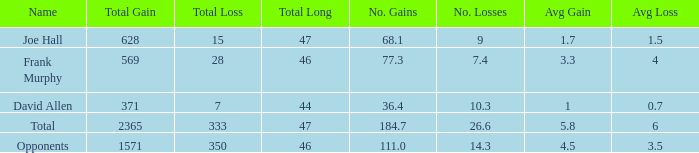Which Avg/G is the lowest one that has a Long smaller than 47, and a Name of frank murphy, and a Gain smaller than 569? None. 